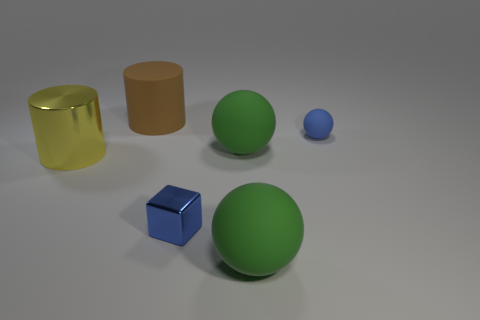Add 1 big metal cylinders. How many objects exist? 7 Subtract all cylinders. How many objects are left? 4 Subtract 0 brown spheres. How many objects are left? 6 Subtract all big green matte spheres. Subtract all big brown things. How many objects are left? 3 Add 1 big objects. How many big objects are left? 5 Add 3 big gray matte blocks. How many big gray matte blocks exist? 3 